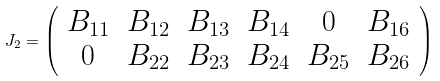Convert formula to latex. <formula><loc_0><loc_0><loc_500><loc_500>J _ { 2 } = \left ( \begin{array} { c c c c c c } B _ { 1 1 } & B _ { 1 2 } & B _ { 1 3 } & B _ { 1 4 } & 0 & B _ { 1 6 } \\ 0 & B _ { 2 2 } & B _ { 2 3 } & B _ { 2 4 } & B _ { 2 5 } & B _ { 2 6 } \end{array} \right )</formula> 